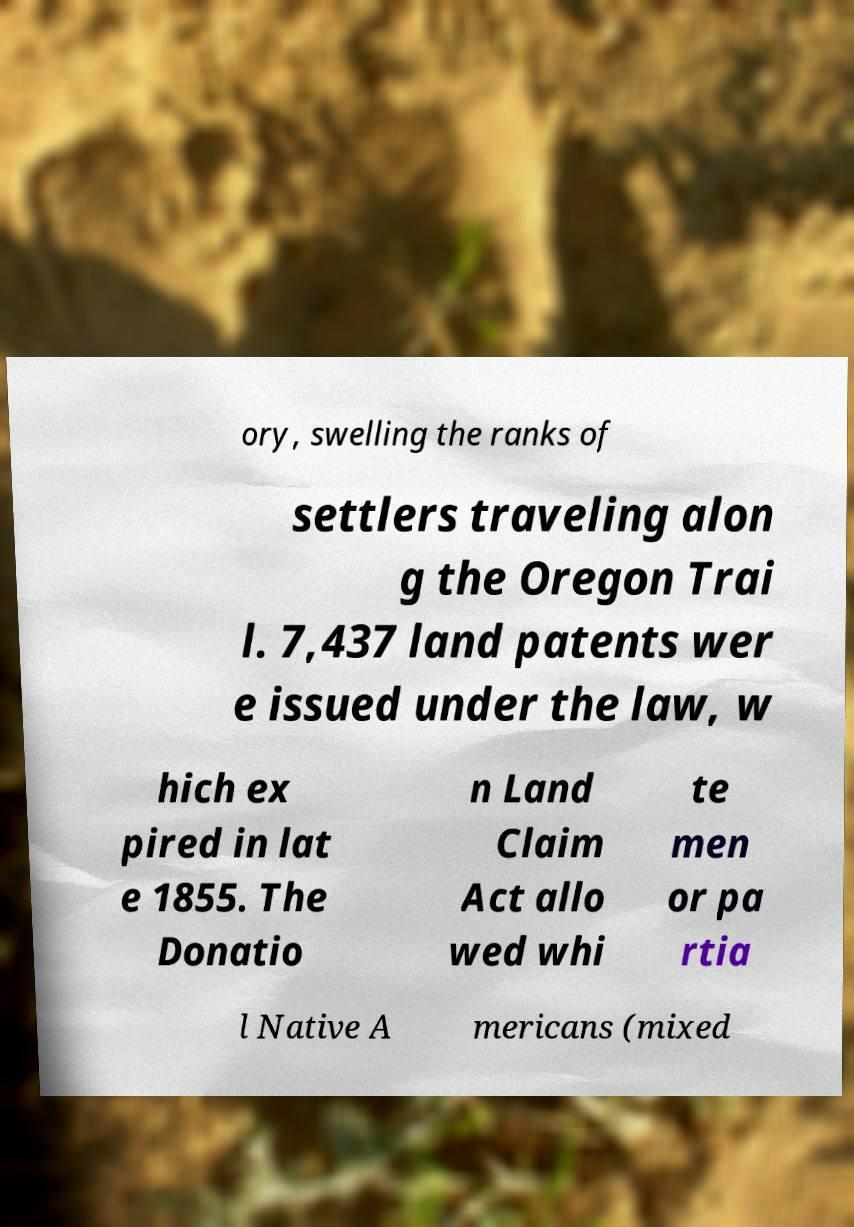There's text embedded in this image that I need extracted. Can you transcribe it verbatim? ory, swelling the ranks of settlers traveling alon g the Oregon Trai l. 7,437 land patents wer e issued under the law, w hich ex pired in lat e 1855. The Donatio n Land Claim Act allo wed whi te men or pa rtia l Native A mericans (mixed 